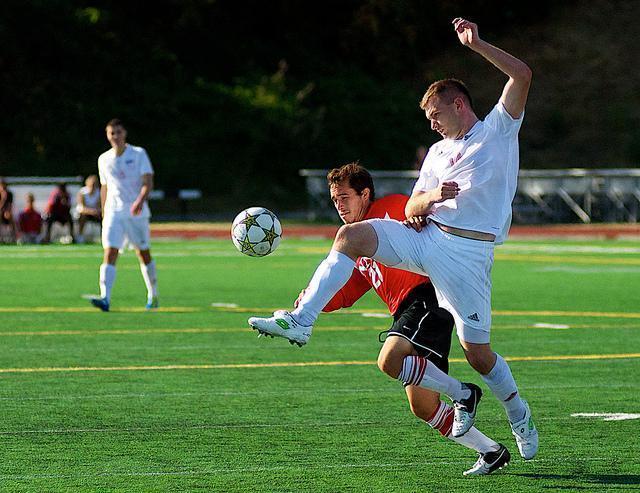How many people are wearing a red shirt?
Give a very brief answer. 1. How many people are there?
Give a very brief answer. 3. 